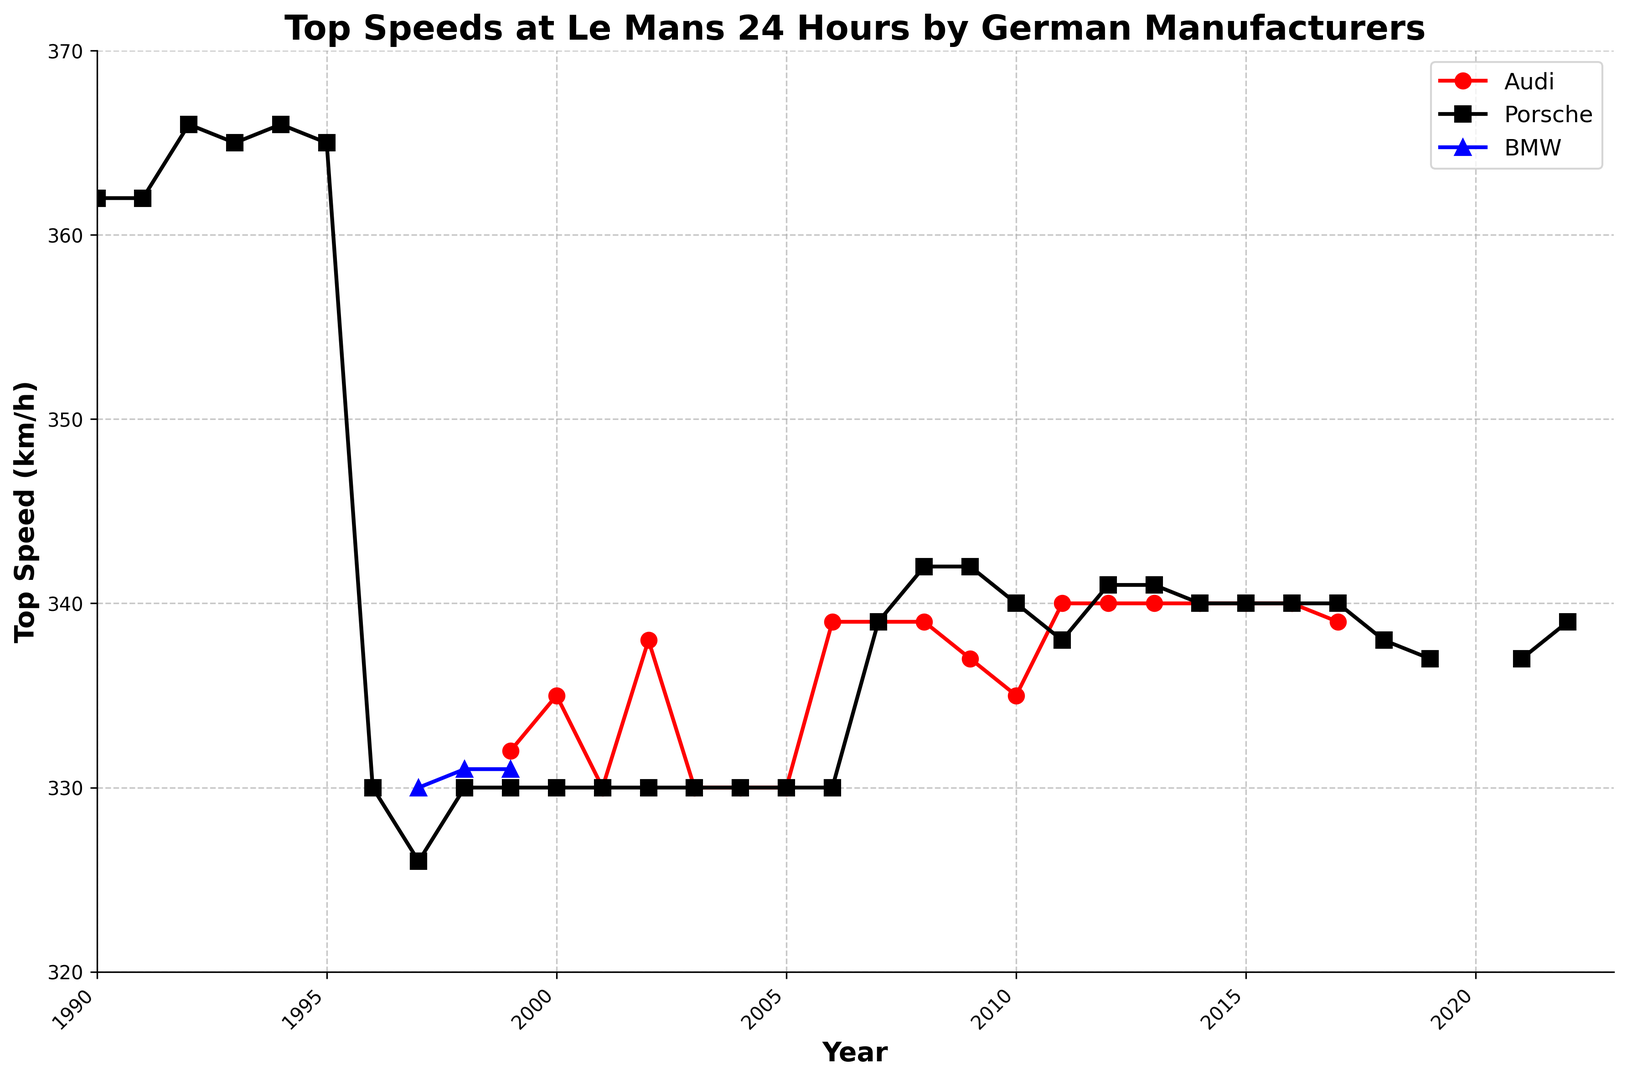Which manufacturer consistently achieved top speeds around 330 km/h from 1990 to 2022? Looking at the figure, Porsche is the manufacturer that consistently recorded top speeds close to 330 km/h throughout the years from 1990 to 2022 without significant deviation.
Answer: Porsche In which year did all three manufacturers simultaneously achieve a top speed of around 330 km/h? The data shows that in 1999, Audi, Porsche, and BMW all achieved a top speed around 330 km/h.
Answer: 1999 Which manufacturer achieved the highest top speed recorded in the data set, and what was the value? The highest top speed recorded is achieved by Porsche, which reached 366 km/h in 1992 and 1994.
Answer: Porsche, 366 km/h In which years did Audi achieve a top speed of 339 km/h? Audi hit a top speed of 339 km/h in the years 2006, 2007, and 2008.
Answer: 2006, 2007, 2008 Compare the top speeds of BMW and Porsche in 1998. Which manufacturer had a higher top speed and by how much? BMW achieved a top speed of 331 km/h in 1998, while Porsche reached 330 km/h. The difference is 1 km/h in favor of BMW.
Answer: BMW by 1 km/h During which year did Audi reach its highest top speed, and what was the speed? Audi's highest recorded top speed was 340 km/h in 2011, 2012, 2013, 2014, 2015, and 2016.
Answer: 2011-2016, 340 km/h What is the average top speed achieved by Porsche from 2000 to 2017? Adding the top speeds achieved by Porsche from 2000 to 2017 and then dividing by the number of years, ((330+330+330+330+330+330+339+342+342+340+338+341+341+340+340+340+340)/18) gives an average of approximately 337 km/h.
Answer: 337 km/h Identify any gaps in the data for all manufacturers. Which years do not have any top speed data recorded? The years when all manufacturers did not have any top speed data recorded are 2020.
Answer: 2020 Which year saw the largest difference in top speeds achieved by Audi and Porsche? What is the difference? The largest difference between Audi and Porsche's top speeds is seen in 2008, where Audi achieved 339 km/h and Porsche 342 km/h, resulting in a difference of 3 km/h.
Answer: 2008, 3 km/h 